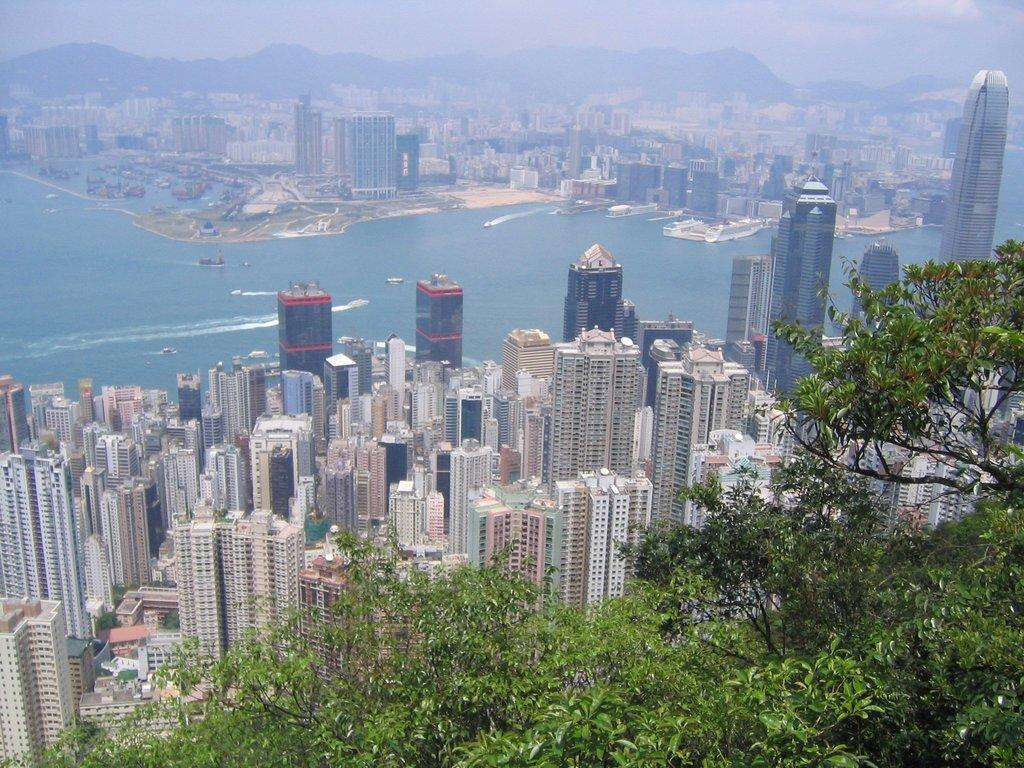What type of structures can be seen in the image? There is a group of buildings in the image. What natural elements are present in the image? There are trees and mountains in the image. What body of water is visible in the image? There is water visible in the image. What type of ring can be seen on the mountain in the image? There is no ring present on the mountain in the image. What type of veil is covering the trees in the image? There is no veil present on the trees in the image. 